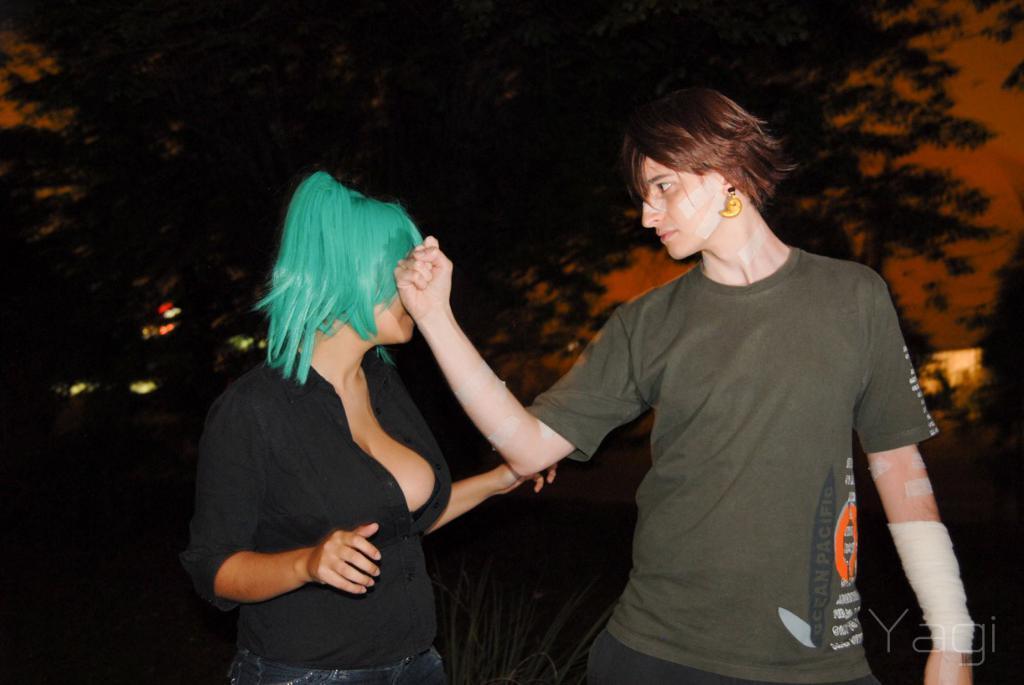Could you give a brief overview of what you see in this image? In this image we can see two persons standing on the ground. In the background we can see sky, trees and grass. 